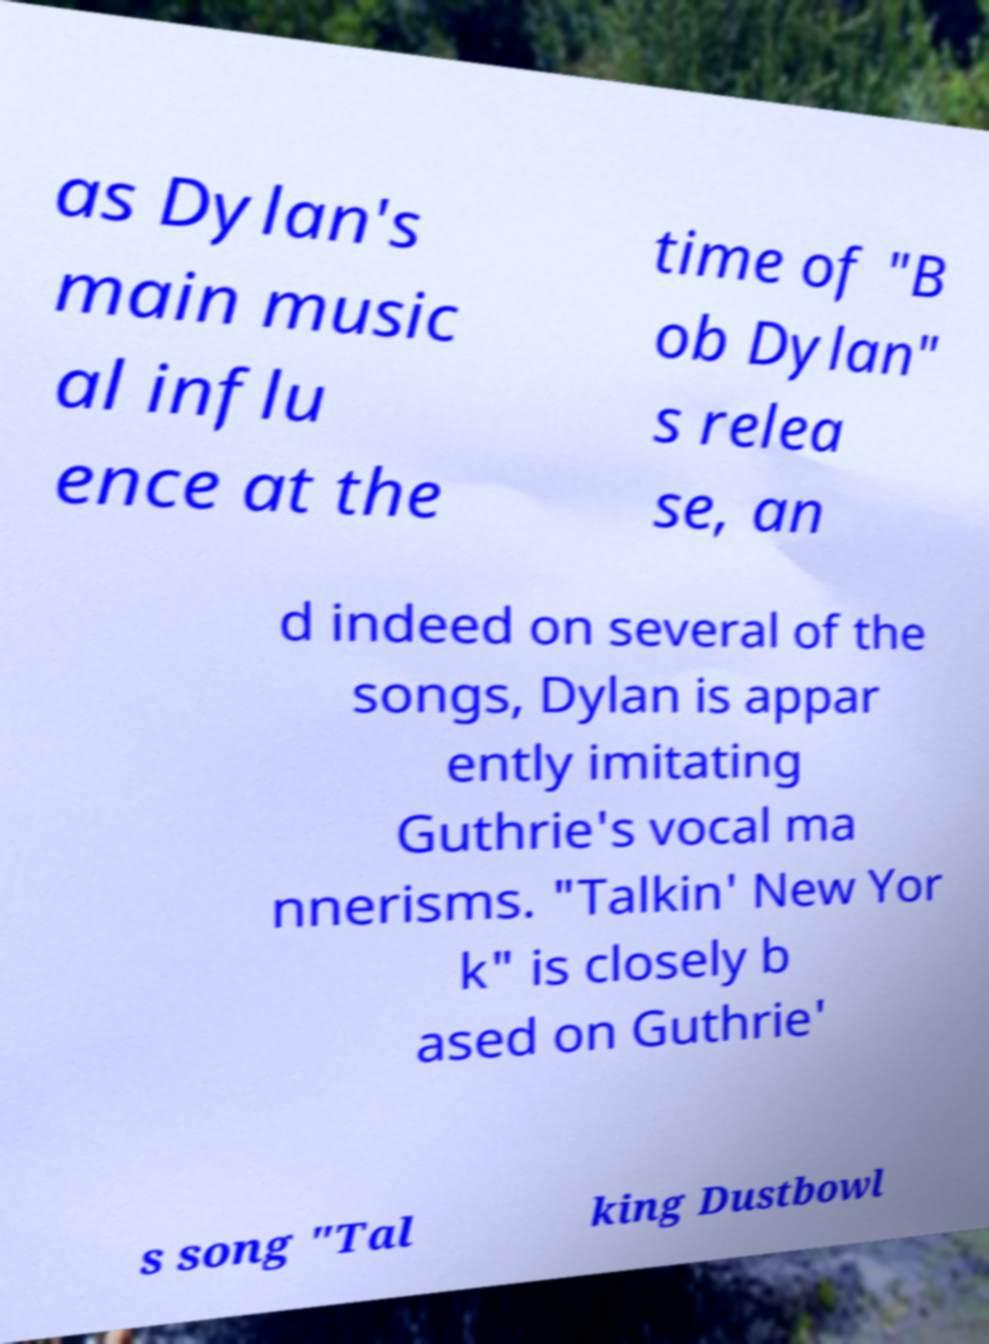Could you extract and type out the text from this image? as Dylan's main music al influ ence at the time of "B ob Dylan" s relea se, an d indeed on several of the songs, Dylan is appar ently imitating Guthrie's vocal ma nnerisms. "Talkin' New Yor k" is closely b ased on Guthrie' s song "Tal king Dustbowl 